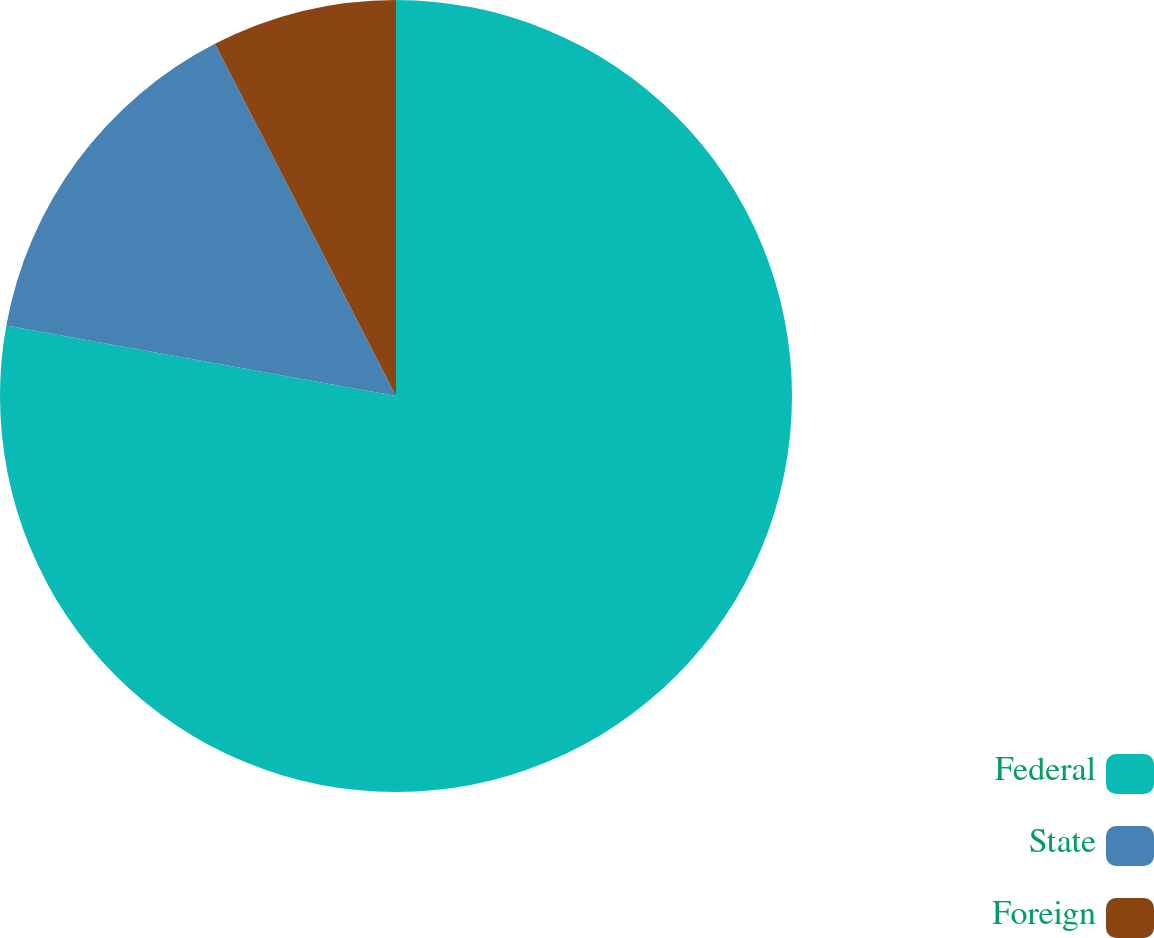<chart> <loc_0><loc_0><loc_500><loc_500><pie_chart><fcel>Federal<fcel>State<fcel>Foreign<nl><fcel>77.85%<fcel>14.59%<fcel>7.56%<nl></chart> 